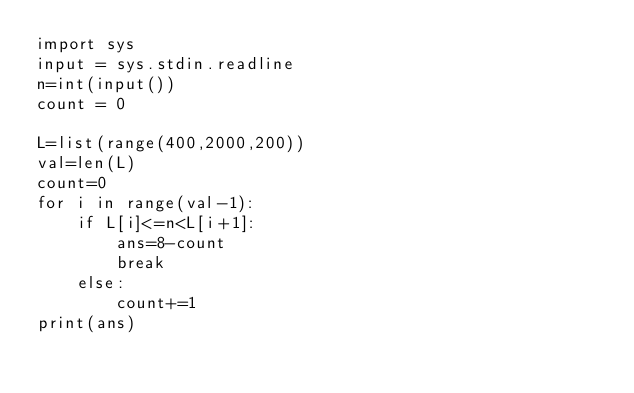Convert code to text. <code><loc_0><loc_0><loc_500><loc_500><_Python_>import sys
input = sys.stdin.readline
n=int(input())
count = 0

L=list(range(400,2000,200))
val=len(L)
count=0
for i in range(val-1):
    if L[i]<=n<L[i+1]:
        ans=8-count
        break
    else:
        count+=1
print(ans)
</code> 